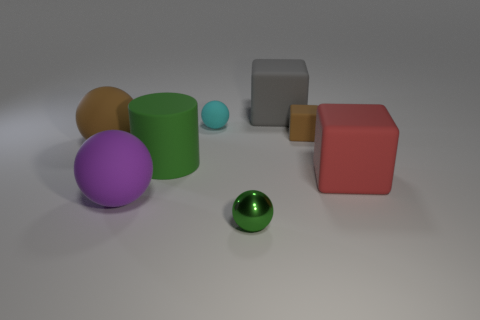Add 1 rubber objects. How many objects exist? 9 Subtract all blocks. How many objects are left? 5 Subtract 1 green spheres. How many objects are left? 7 Subtract all purple balls. Subtract all red rubber things. How many objects are left? 6 Add 2 rubber cylinders. How many rubber cylinders are left? 3 Add 1 large rubber cubes. How many large rubber cubes exist? 3 